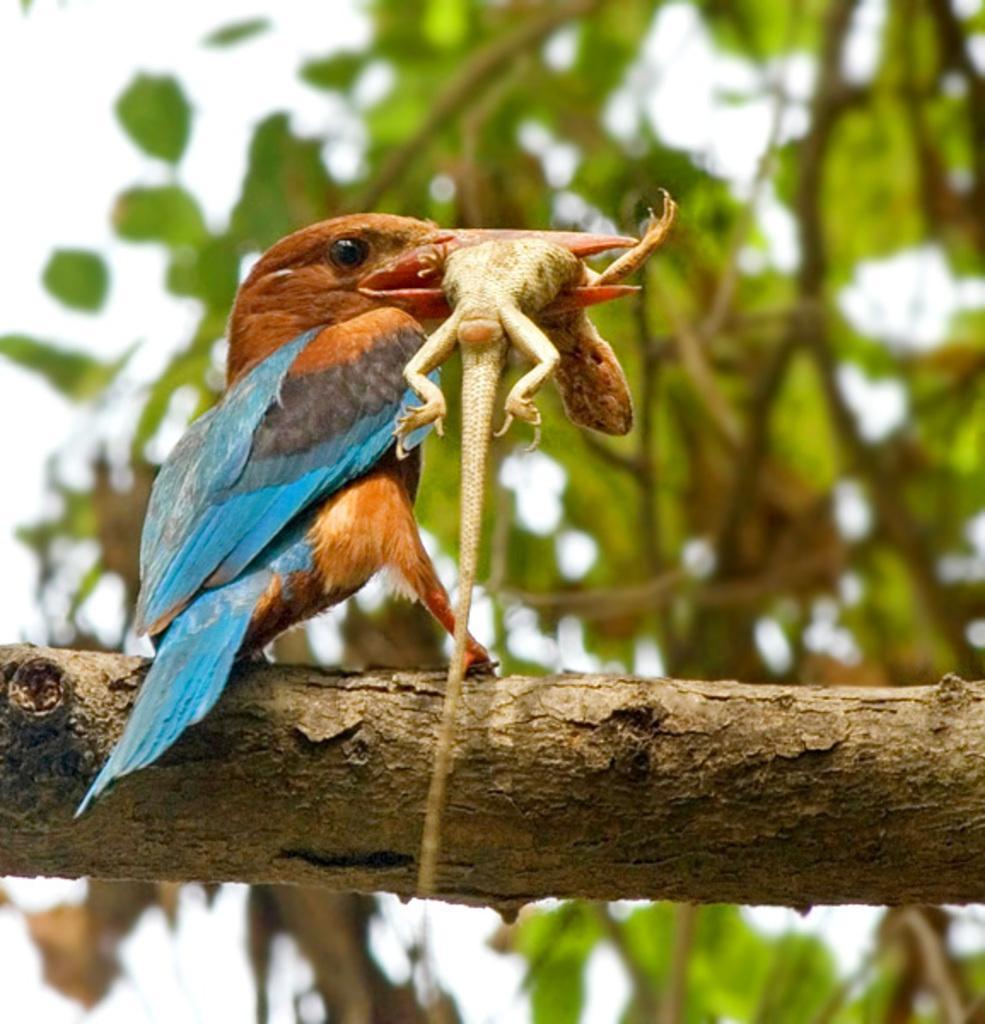Describe this image in one or two sentences. In this image we can see a bird holding a lizard with its mouth. In the background we can see branches, leaves, and sky. 